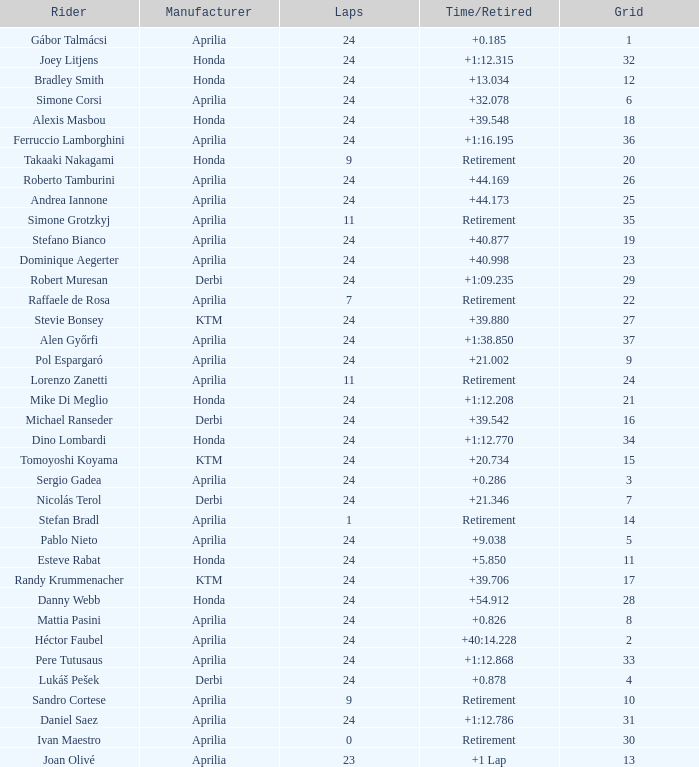What is the time with 10 grids? Retirement. 